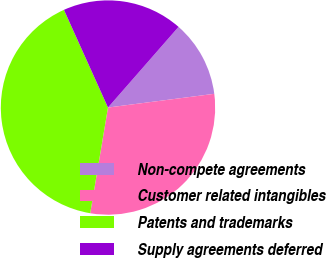Convert chart to OTSL. <chart><loc_0><loc_0><loc_500><loc_500><pie_chart><fcel>Non-compete agreements<fcel>Customer related intangibles<fcel>Patents and trademarks<fcel>Supply agreements deferred<nl><fcel>11.52%<fcel>29.7%<fcel>40.61%<fcel>18.18%<nl></chart> 